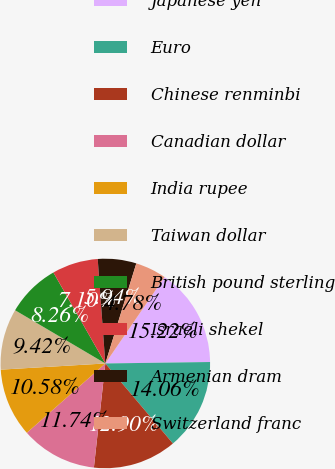Convert chart to OTSL. <chart><loc_0><loc_0><loc_500><loc_500><pie_chart><fcel>Japanese yen<fcel>Euro<fcel>Chinese renminbi<fcel>Canadian dollar<fcel>India rupee<fcel>Taiwan dollar<fcel>British pound sterling<fcel>Israeli shekel<fcel>Armenian dram<fcel>Switzerland franc<nl><fcel>15.22%<fcel>14.06%<fcel>12.9%<fcel>11.74%<fcel>10.58%<fcel>9.42%<fcel>8.26%<fcel>7.1%<fcel>5.94%<fcel>4.78%<nl></chart> 